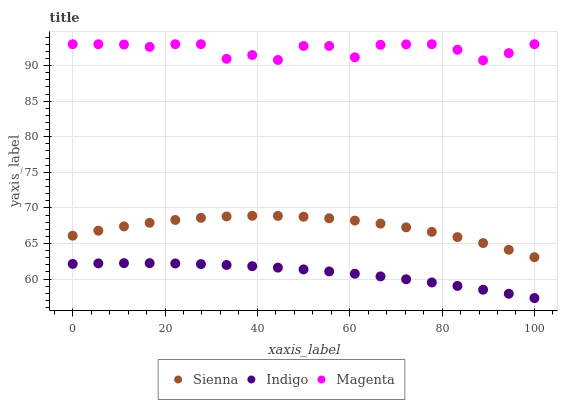Does Indigo have the minimum area under the curve?
Answer yes or no. Yes. Does Magenta have the maximum area under the curve?
Answer yes or no. Yes. Does Magenta have the minimum area under the curve?
Answer yes or no. No. Does Indigo have the maximum area under the curve?
Answer yes or no. No. Is Indigo the smoothest?
Answer yes or no. Yes. Is Magenta the roughest?
Answer yes or no. Yes. Is Magenta the smoothest?
Answer yes or no. No. Is Indigo the roughest?
Answer yes or no. No. Does Indigo have the lowest value?
Answer yes or no. Yes. Does Magenta have the lowest value?
Answer yes or no. No. Does Magenta have the highest value?
Answer yes or no. Yes. Does Indigo have the highest value?
Answer yes or no. No. Is Indigo less than Magenta?
Answer yes or no. Yes. Is Sienna greater than Indigo?
Answer yes or no. Yes. Does Indigo intersect Magenta?
Answer yes or no. No. 